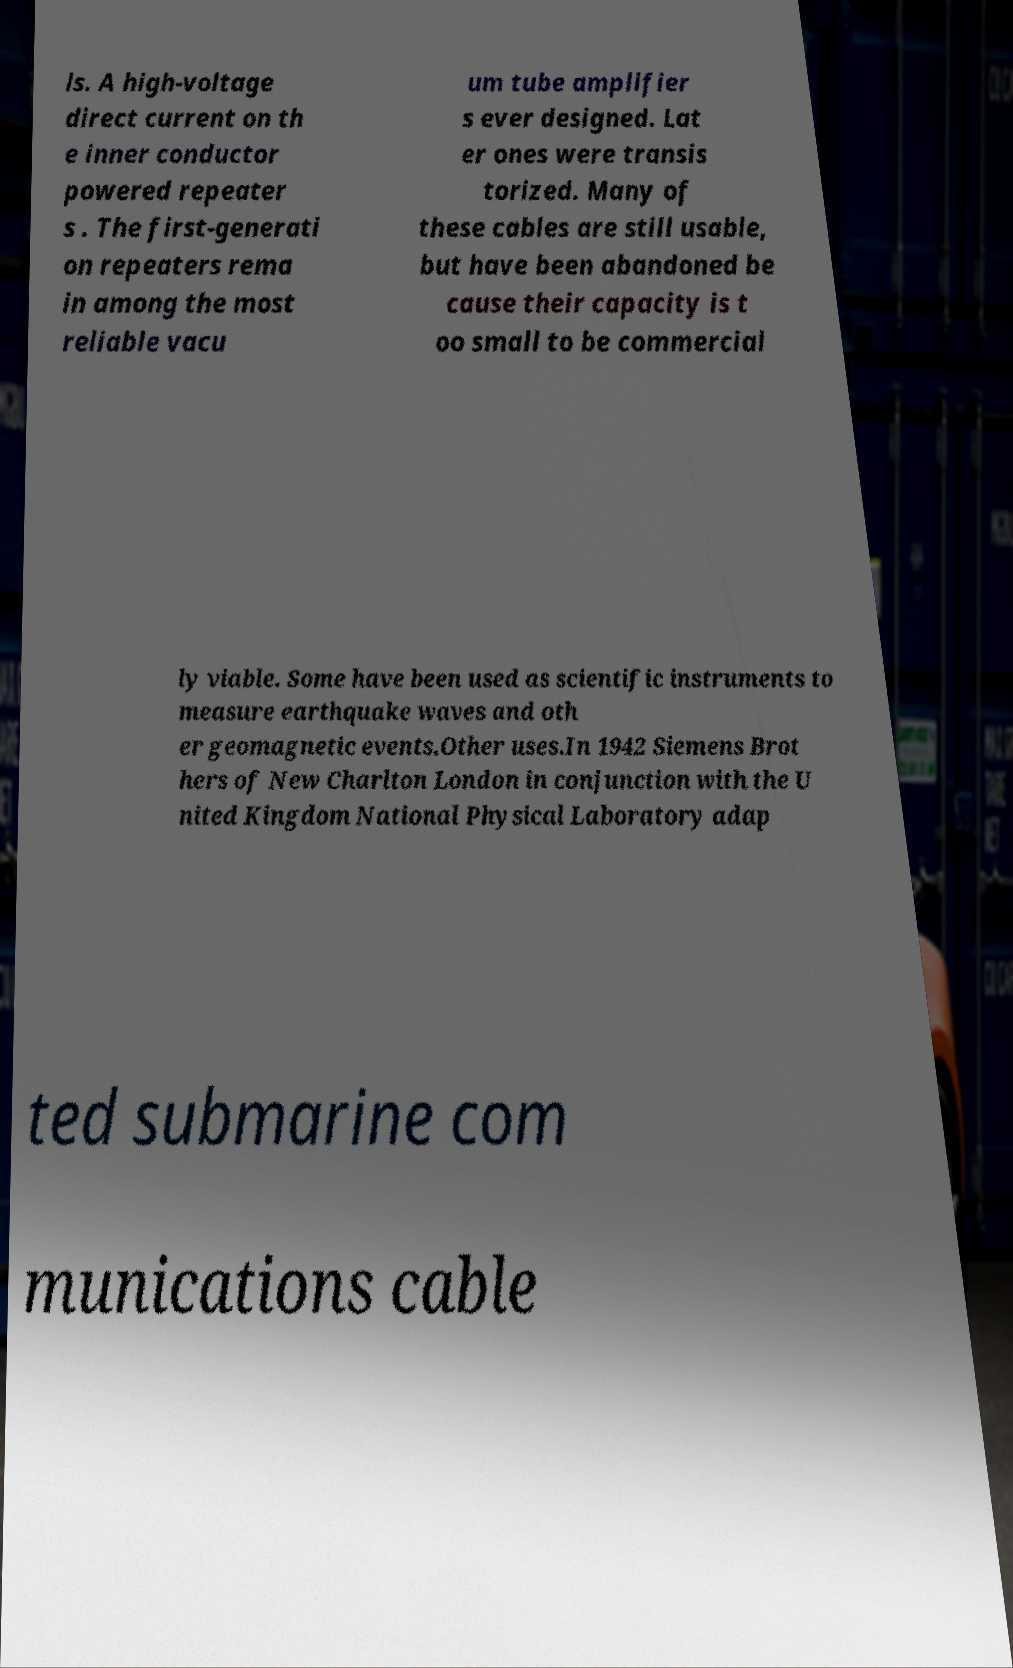Please identify and transcribe the text found in this image. ls. A high-voltage direct current on th e inner conductor powered repeater s . The first-generati on repeaters rema in among the most reliable vacu um tube amplifier s ever designed. Lat er ones were transis torized. Many of these cables are still usable, but have been abandoned be cause their capacity is t oo small to be commercial ly viable. Some have been used as scientific instruments to measure earthquake waves and oth er geomagnetic events.Other uses.In 1942 Siemens Brot hers of New Charlton London in conjunction with the U nited Kingdom National Physical Laboratory adap ted submarine com munications cable 